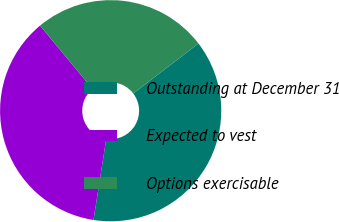Convert chart to OTSL. <chart><loc_0><loc_0><loc_500><loc_500><pie_chart><fcel>Outstanding at December 31<fcel>Expected to vest<fcel>Options exercisable<nl><fcel>37.88%<fcel>36.49%<fcel>25.63%<nl></chart> 